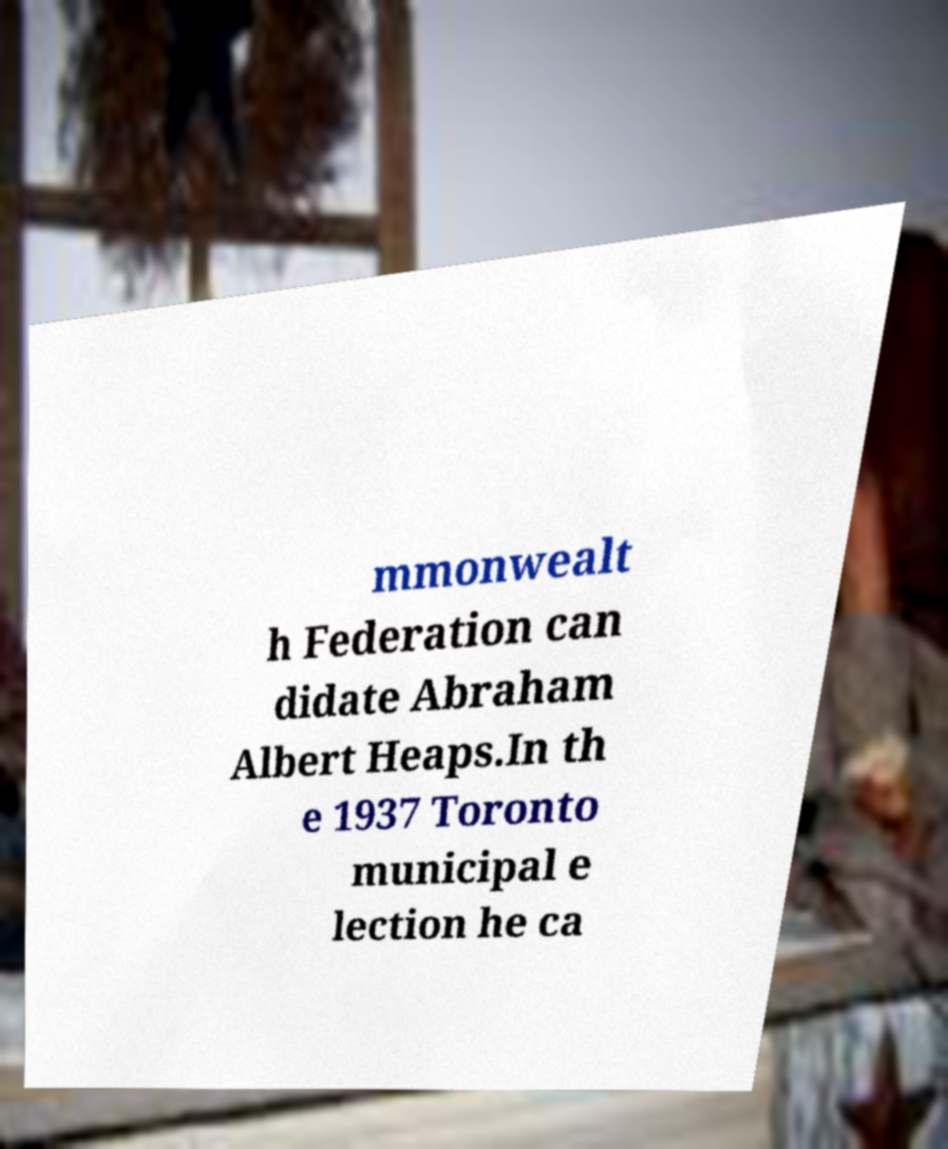I need the written content from this picture converted into text. Can you do that? mmonwealt h Federation can didate Abraham Albert Heaps.In th e 1937 Toronto municipal e lection he ca 